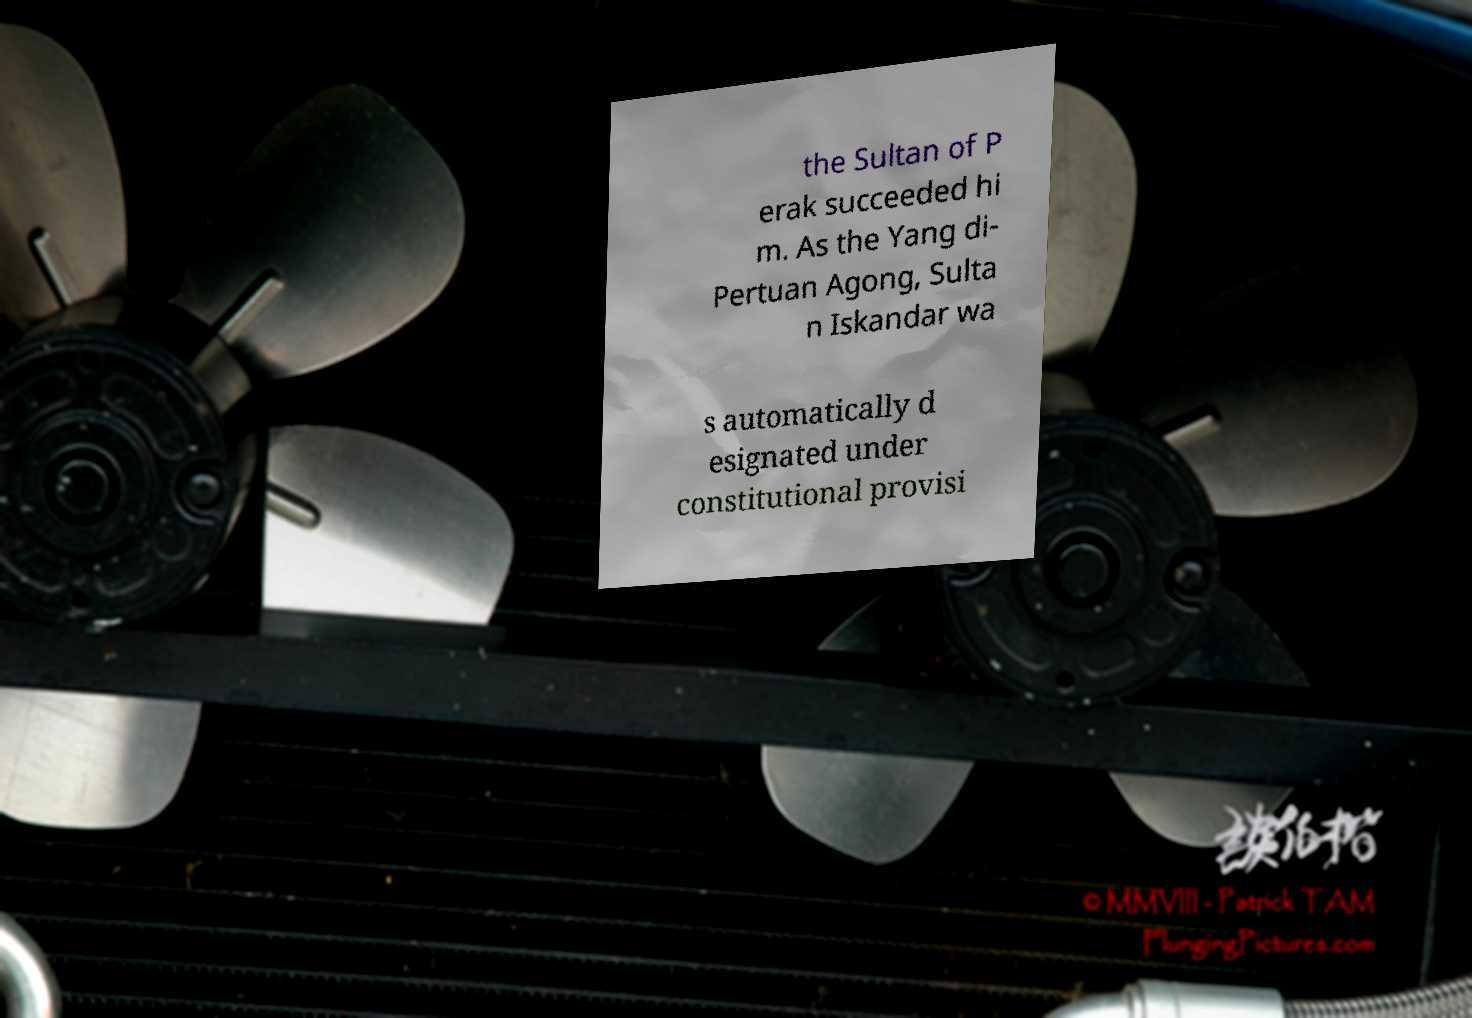Can you accurately transcribe the text from the provided image for me? the Sultan of P erak succeeded hi m. As the Yang di- Pertuan Agong, Sulta n Iskandar wa s automatically d esignated under constitutional provisi 